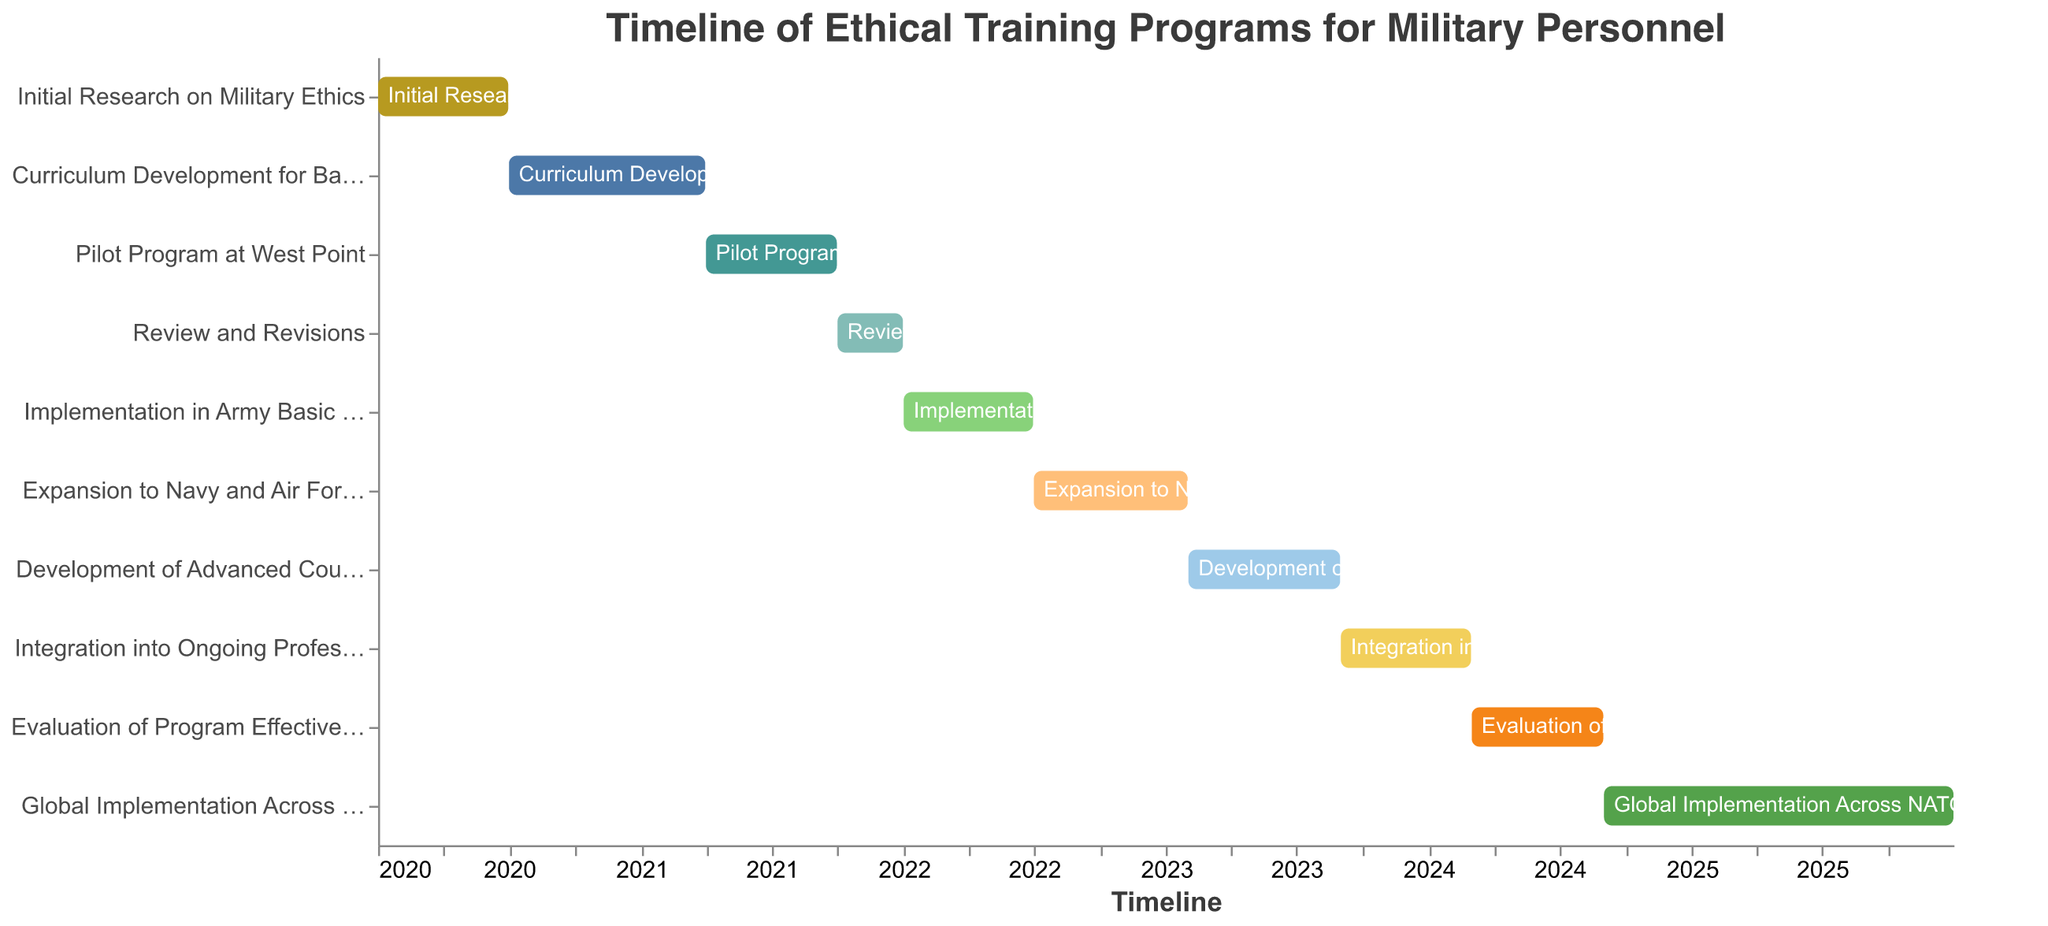What's the title of the Gantt Chart? The title of the Gantt Chart is typically found above the chart itself, providing an overview of what the chart represents. Here, the title is at the top center of the chart.
Answer: Timeline of Ethical Training Programs for Military Personnel Which task started first? To determine which task started first, look at the earliest date along the timeline (x-axis). The task associated with this earliest date is the starting task.
Answer: Initial Research on Military Ethics Which task has the longest duration? The duration of each task can be determined by the length of the bar representing the task. The task with the longest bar has the longest duration.
Answer: Global Implementation Across NATO Forces How many tasks are scheduled to be completed by the end of 2024? To find this out, check the end dates of each task and count how many end on or before December 31, 2024.
Answer: Nine tasks Which task overlaps with the "Pilot Program at West Point"? To discover overlapping tasks, identify which other bars span over the same time period as the "Pilot Program at West Point" from April 2021 to September 2021.
Answer: Review and Revisions What is the total duration of the "Evaluation of Program Effectiveness"? Calculate the duration by finding the difference between the start and end dates of the task.
Answer: 6 months How long after the "Initial Research on Military Ethics" did the "Pilot Program at West Point" begin? Calculate the time between the end date of the initial research (June 30, 2020) and the start date of the pilot program (April 1, 2021).
Answer: Approximately 9 months Which task immediately follows the "Review and Revisions"? Look at the timeline and see which task starts right after the end date of the "Review and Revisions" task's end date, which is December 31, 2021.
Answer: Implementation in Army Basic Training Which task takes place entirely in the year 2023? Identify the task(s) with both start and end dates falling within the year 2023.
Answer: Development of Advanced Course for Officers What is the final task in the timeline? To determine the final task, find which task has the latest end date along the timeline.
Answer: Global Implementation Across NATO Forces 